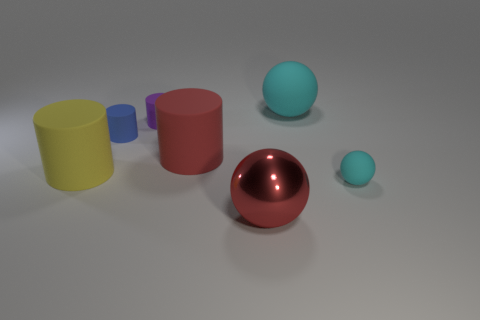Subtract all large spheres. How many spheres are left? 1 Add 2 big spheres. How many objects exist? 9 Subtract all purple cylinders. How many cylinders are left? 3 Subtract all cylinders. How many objects are left? 3 Subtract 3 balls. How many balls are left? 0 Subtract all green blocks. How many cyan spheres are left? 2 Add 6 big red rubber cylinders. How many big red rubber cylinders exist? 7 Subtract 0 green cylinders. How many objects are left? 7 Subtract all green cylinders. Subtract all green blocks. How many cylinders are left? 4 Subtract all big gray rubber balls. Subtract all tiny blue rubber objects. How many objects are left? 6 